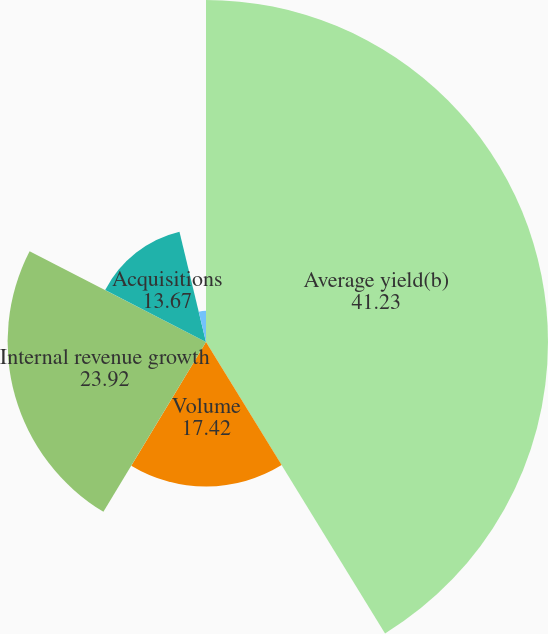<chart> <loc_0><loc_0><loc_500><loc_500><pie_chart><fcel>Average yield(b)<fcel>Volume<fcel>Internal revenue growth<fcel>Acquisitions<fcel>Foreign currency translation<nl><fcel>41.23%<fcel>17.42%<fcel>23.92%<fcel>13.67%<fcel>3.76%<nl></chart> 